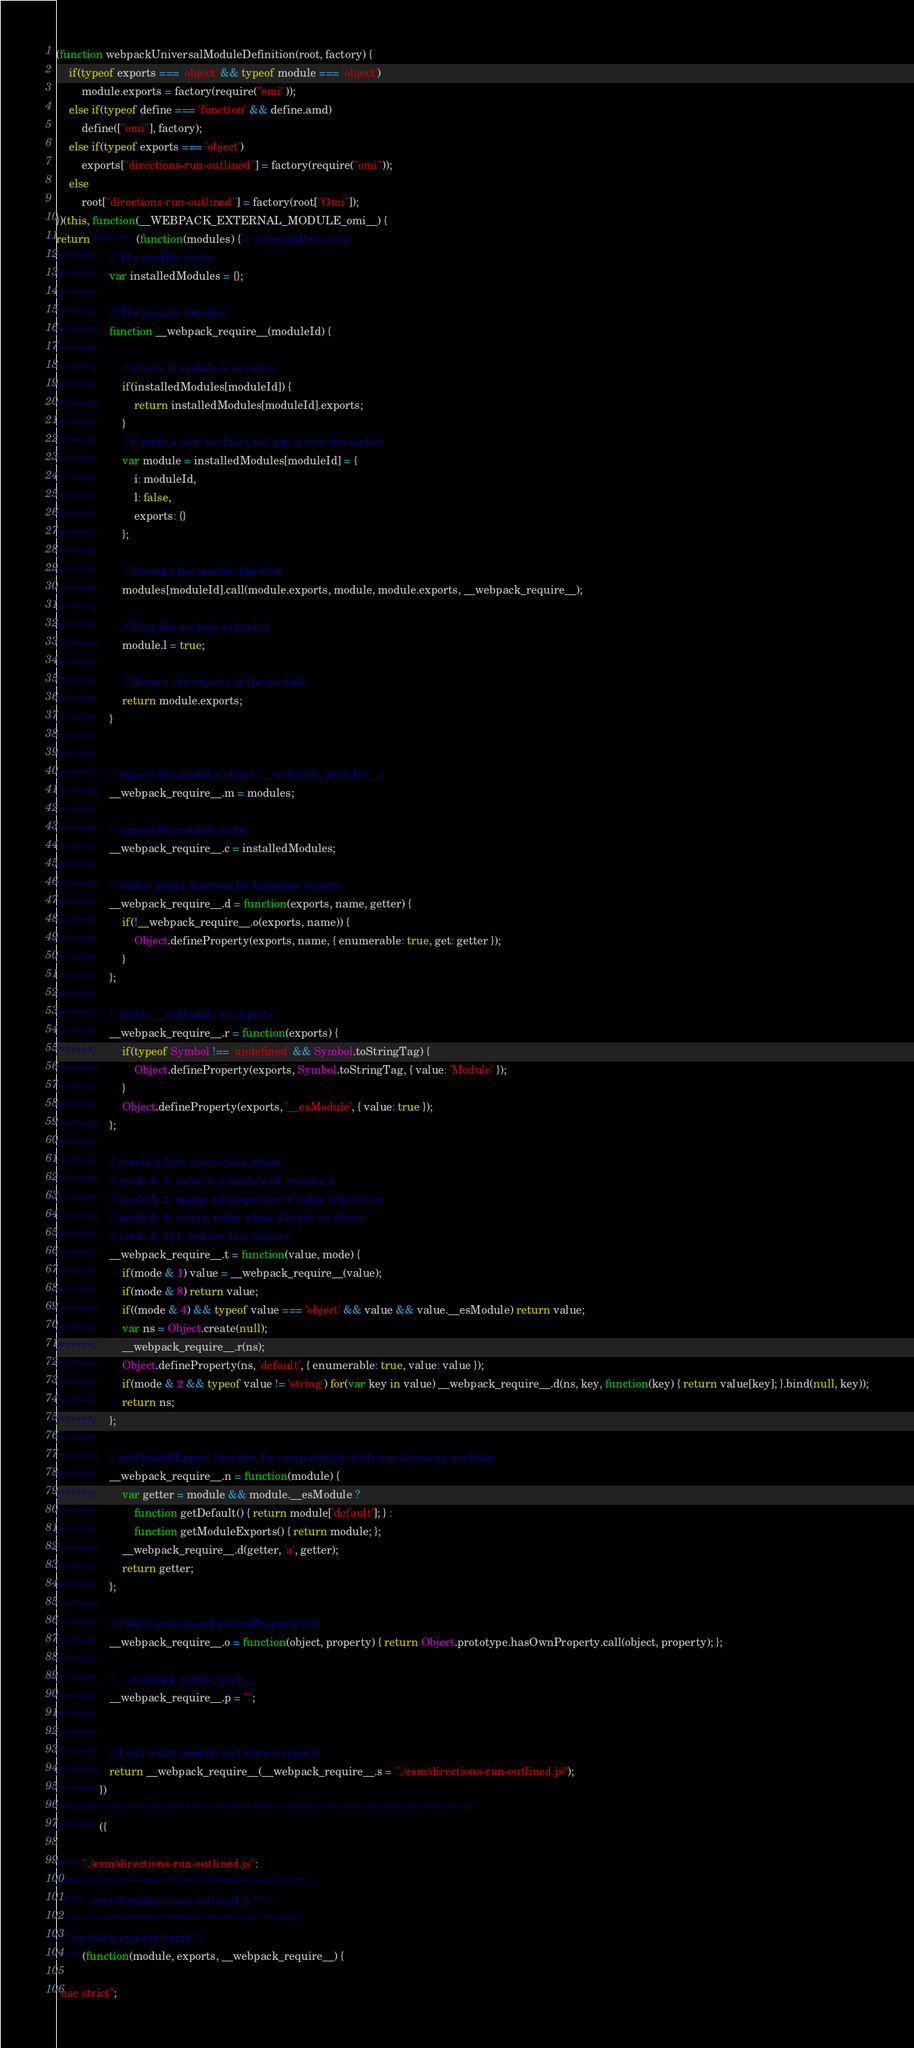Convert code to text. <code><loc_0><loc_0><loc_500><loc_500><_JavaScript_>(function webpackUniversalModuleDefinition(root, factory) {
	if(typeof exports === 'object' && typeof module === 'object')
		module.exports = factory(require("omi"));
	else if(typeof define === 'function' && define.amd)
		define(["omi"], factory);
	else if(typeof exports === 'object')
		exports["directions-run-outlined"] = factory(require("omi"));
	else
		root["directions-run-outlined"] = factory(root["Omi"]);
})(this, function(__WEBPACK_EXTERNAL_MODULE_omi__) {
return /******/ (function(modules) { // webpackBootstrap
/******/ 	// The module cache
/******/ 	var installedModules = {};
/******/
/******/ 	// The require function
/******/ 	function __webpack_require__(moduleId) {
/******/
/******/ 		// Check if module is in cache
/******/ 		if(installedModules[moduleId]) {
/******/ 			return installedModules[moduleId].exports;
/******/ 		}
/******/ 		// Create a new module (and put it into the cache)
/******/ 		var module = installedModules[moduleId] = {
/******/ 			i: moduleId,
/******/ 			l: false,
/******/ 			exports: {}
/******/ 		};
/******/
/******/ 		// Execute the module function
/******/ 		modules[moduleId].call(module.exports, module, module.exports, __webpack_require__);
/******/
/******/ 		// Flag the module as loaded
/******/ 		module.l = true;
/******/
/******/ 		// Return the exports of the module
/******/ 		return module.exports;
/******/ 	}
/******/
/******/
/******/ 	// expose the modules object (__webpack_modules__)
/******/ 	__webpack_require__.m = modules;
/******/
/******/ 	// expose the module cache
/******/ 	__webpack_require__.c = installedModules;
/******/
/******/ 	// define getter function for harmony exports
/******/ 	__webpack_require__.d = function(exports, name, getter) {
/******/ 		if(!__webpack_require__.o(exports, name)) {
/******/ 			Object.defineProperty(exports, name, { enumerable: true, get: getter });
/******/ 		}
/******/ 	};
/******/
/******/ 	// define __esModule on exports
/******/ 	__webpack_require__.r = function(exports) {
/******/ 		if(typeof Symbol !== 'undefined' && Symbol.toStringTag) {
/******/ 			Object.defineProperty(exports, Symbol.toStringTag, { value: 'Module' });
/******/ 		}
/******/ 		Object.defineProperty(exports, '__esModule', { value: true });
/******/ 	};
/******/
/******/ 	// create a fake namespace object
/******/ 	// mode & 1: value is a module id, require it
/******/ 	// mode & 2: merge all properties of value into the ns
/******/ 	// mode & 4: return value when already ns object
/******/ 	// mode & 8|1: behave like require
/******/ 	__webpack_require__.t = function(value, mode) {
/******/ 		if(mode & 1) value = __webpack_require__(value);
/******/ 		if(mode & 8) return value;
/******/ 		if((mode & 4) && typeof value === 'object' && value && value.__esModule) return value;
/******/ 		var ns = Object.create(null);
/******/ 		__webpack_require__.r(ns);
/******/ 		Object.defineProperty(ns, 'default', { enumerable: true, value: value });
/******/ 		if(mode & 2 && typeof value != 'string') for(var key in value) __webpack_require__.d(ns, key, function(key) { return value[key]; }.bind(null, key));
/******/ 		return ns;
/******/ 	};
/******/
/******/ 	// getDefaultExport function for compatibility with non-harmony modules
/******/ 	__webpack_require__.n = function(module) {
/******/ 		var getter = module && module.__esModule ?
/******/ 			function getDefault() { return module['default']; } :
/******/ 			function getModuleExports() { return module; };
/******/ 		__webpack_require__.d(getter, 'a', getter);
/******/ 		return getter;
/******/ 	};
/******/
/******/ 	// Object.prototype.hasOwnProperty.call
/******/ 	__webpack_require__.o = function(object, property) { return Object.prototype.hasOwnProperty.call(object, property); };
/******/
/******/ 	// __webpack_public_path__
/******/ 	__webpack_require__.p = "";
/******/
/******/
/******/ 	// Load entry module and return exports
/******/ 	return __webpack_require__(__webpack_require__.s = "./esm/directions-run-outlined.js");
/******/ })
/************************************************************************/
/******/ ({

/***/ "./esm/directions-run-outlined.js":
/*!****************************************!*\
  !*** ./esm/directions-run-outlined.js ***!
  \****************************************/
/*! no static exports found */
/***/ (function(module, exports, __webpack_require__) {

"use strict";</code> 